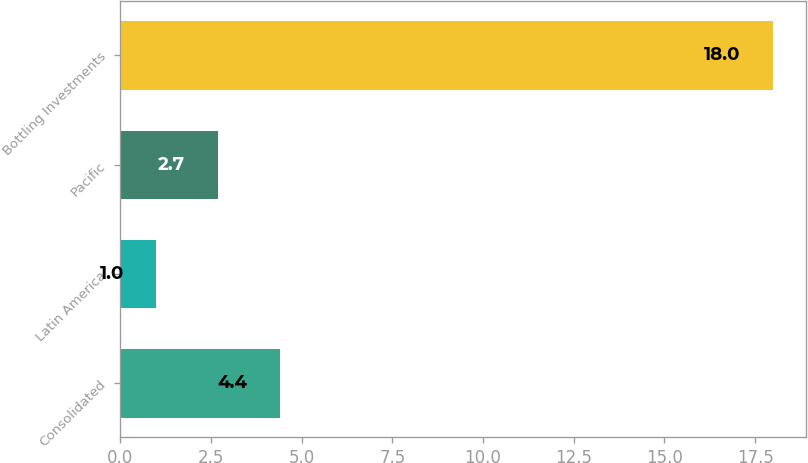Convert chart to OTSL. <chart><loc_0><loc_0><loc_500><loc_500><bar_chart><fcel>Consolidated<fcel>Latin America<fcel>Pacific<fcel>Bottling Investments<nl><fcel>4.4<fcel>1<fcel>2.7<fcel>18<nl></chart> 